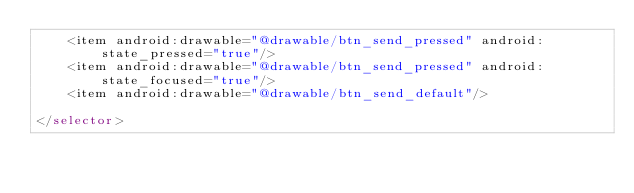<code> <loc_0><loc_0><loc_500><loc_500><_XML_>    <item android:drawable="@drawable/btn_send_pressed" android:state_pressed="true"/>
    <item android:drawable="@drawable/btn_send_pressed" android:state_focused="true"/>
    <item android:drawable="@drawable/btn_send_default"/>

</selector></code> 